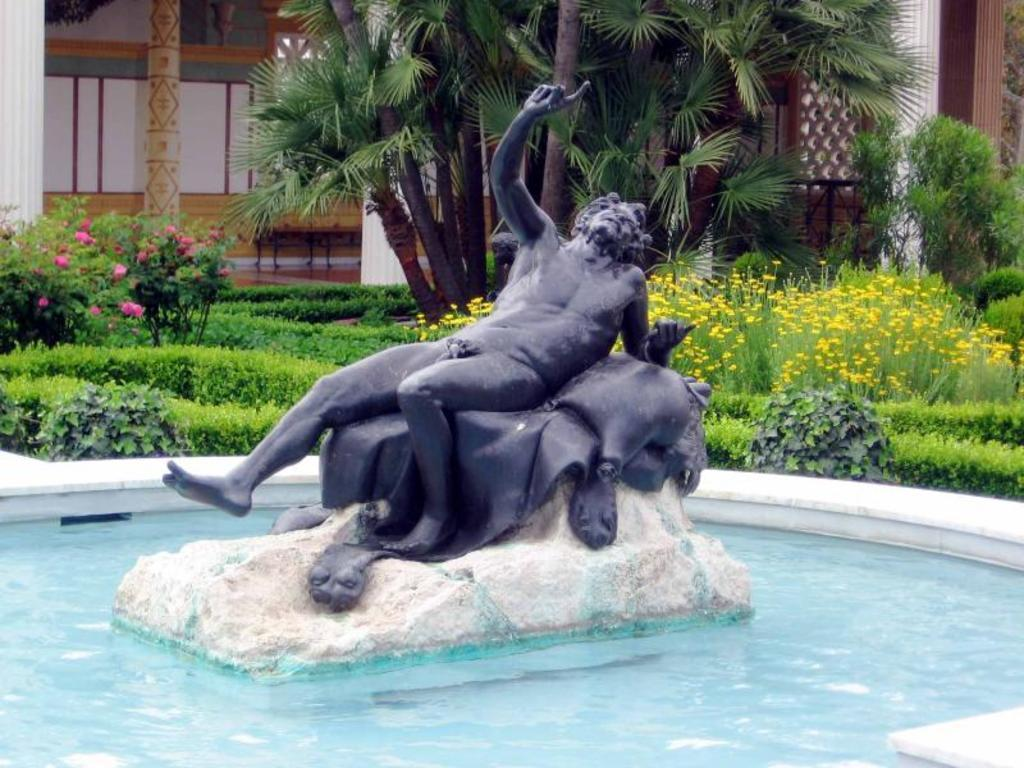What is the main feature in the image? There is a pool in the image. What is located inside the pool? There is a sculpture in the pool. What type of vegetation can be seen in the image? There are plants and trees visible in the image. What architectural elements are present in the image? There are pillars in the image. What type of sticks can be seen in the image? There are no sticks present in the image. 